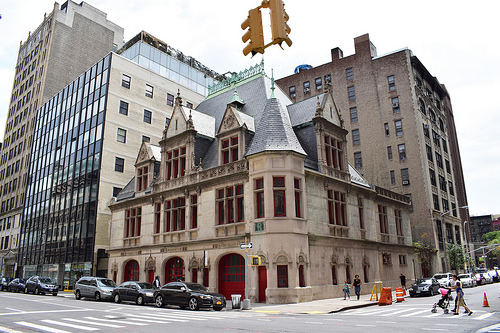<image>
Can you confirm if the car is behind the woman? No. The car is not behind the woman. From this viewpoint, the car appears to be positioned elsewhere in the scene. 